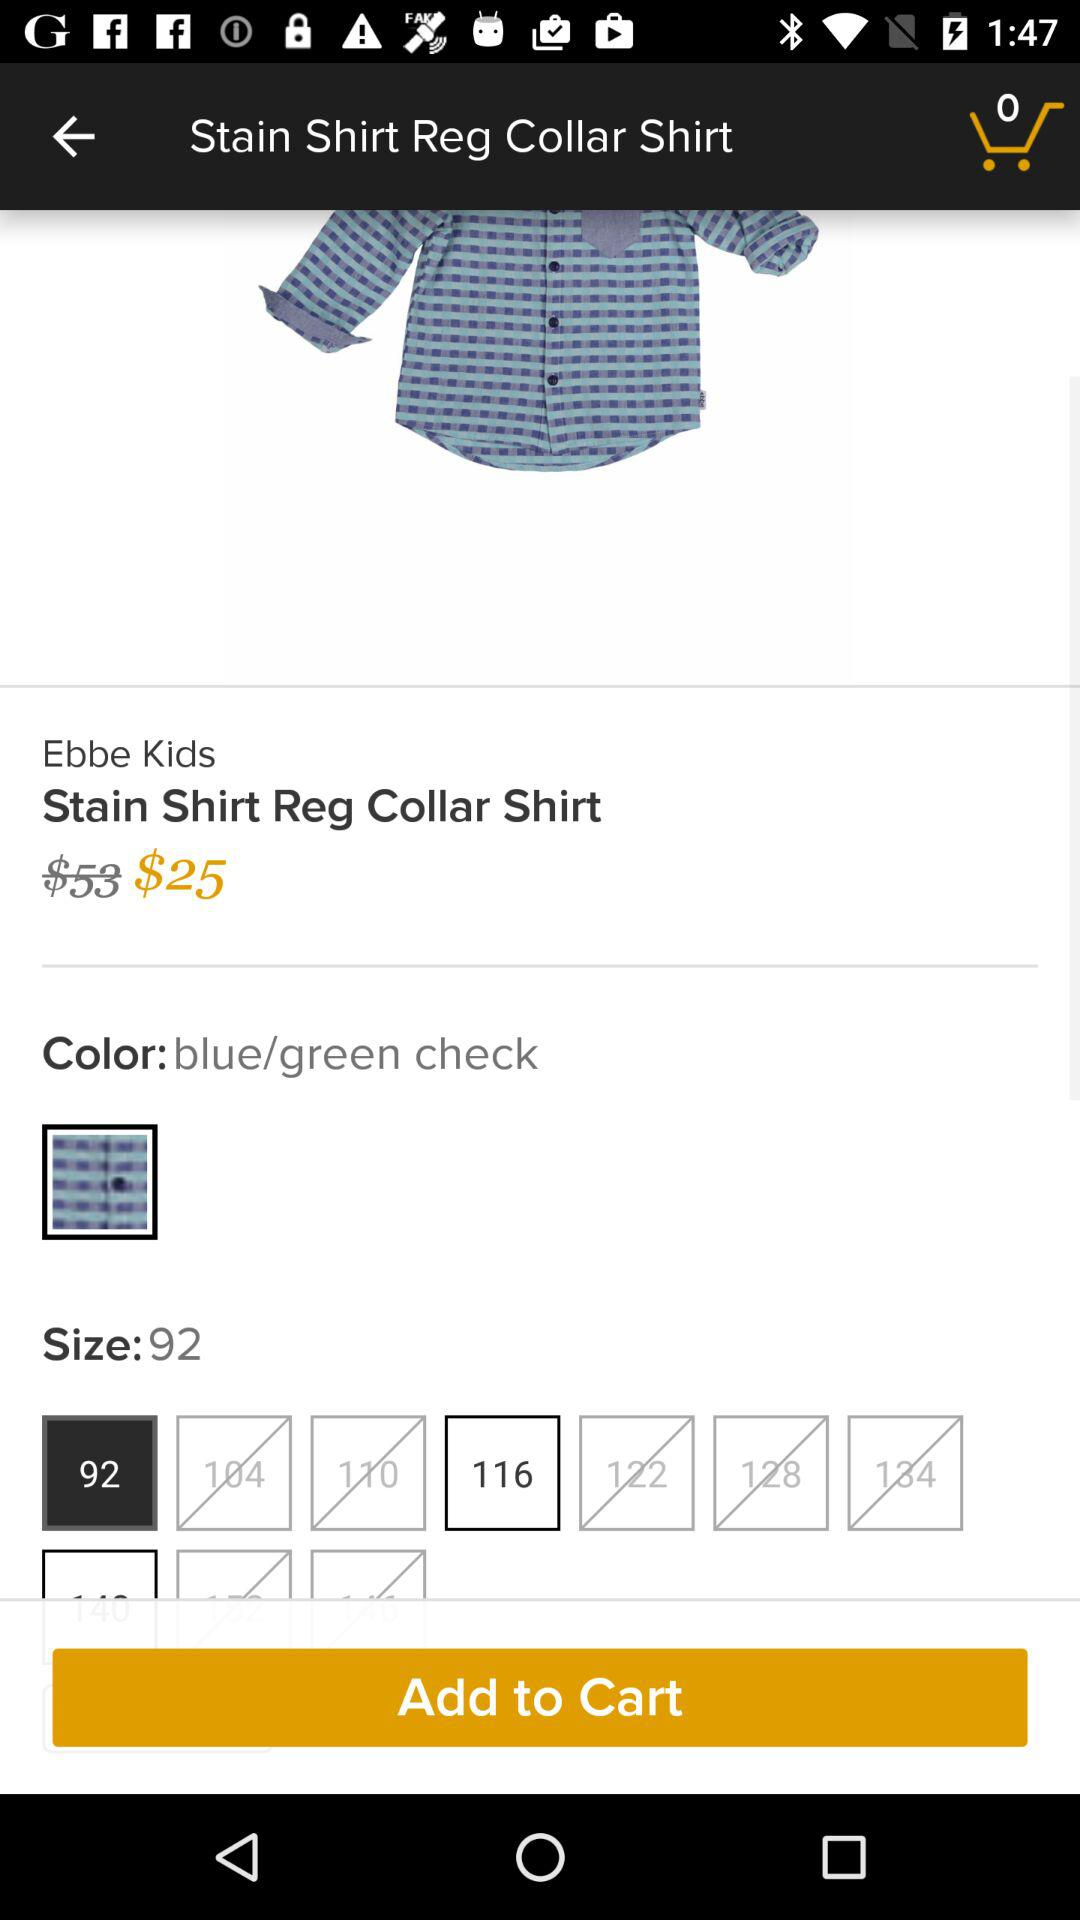What is the mentioned color? The mentioned color is "blue/green check". 